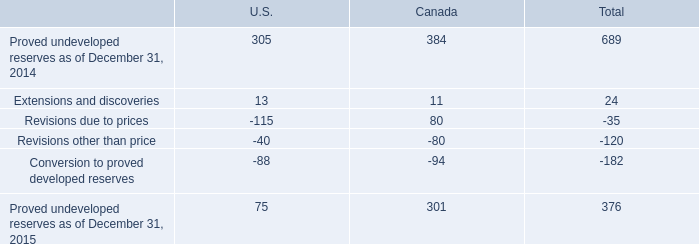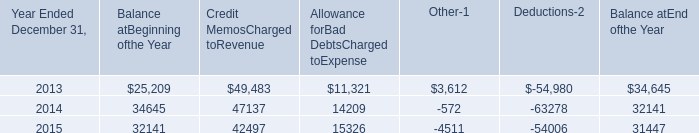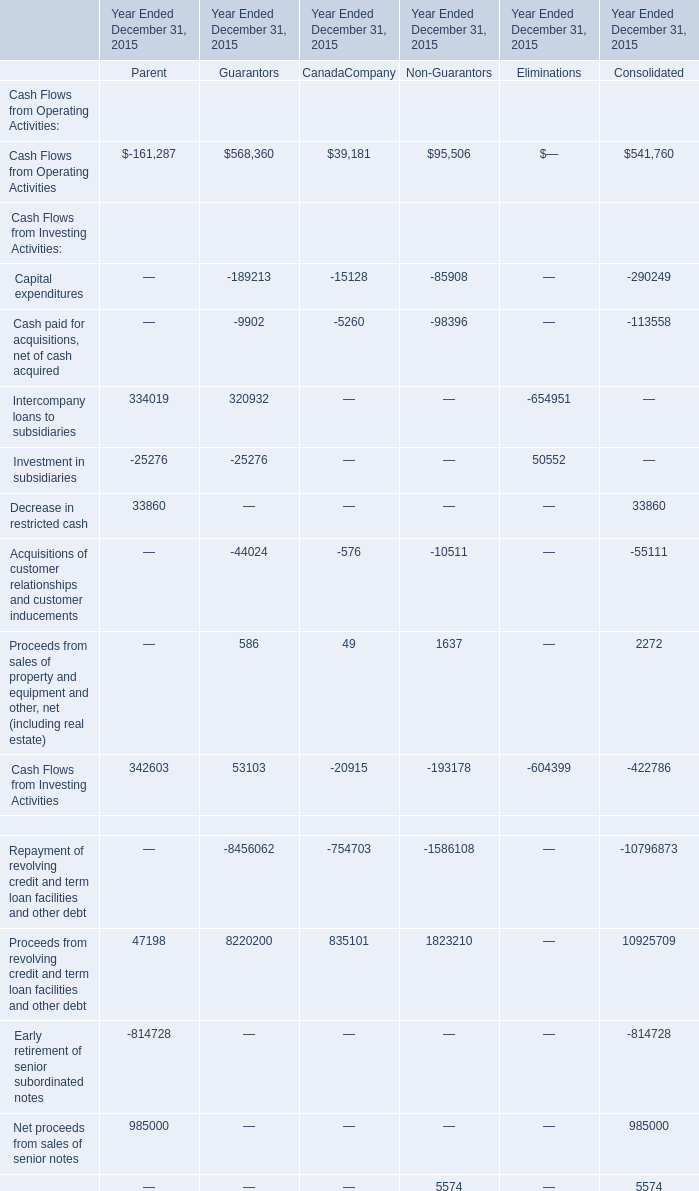what was the total number , in mmboe , of 2014 proved developed reserves? 
Computations: (182 * (100 / 26))
Answer: 700.0. 